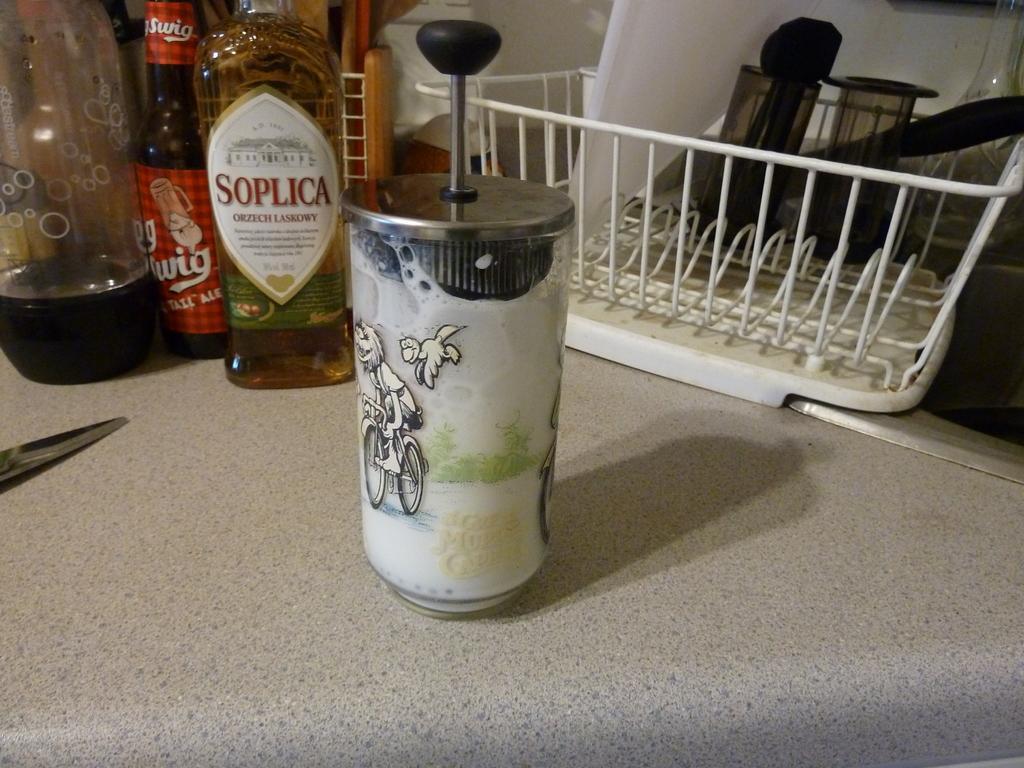Describe this image in one or two sentences. In this picture we can see a glass, couple of bottles and a basket on the table. 